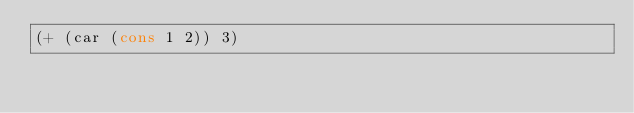Convert code to text. <code><loc_0><loc_0><loc_500><loc_500><_Lisp_>(+ (car (cons 1 2)) 3)
</code> 